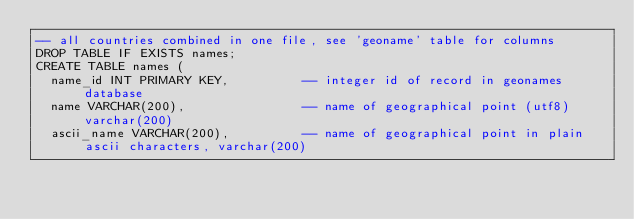Convert code to text. <code><loc_0><loc_0><loc_500><loc_500><_SQL_>-- all countries combined in one file, see 'geoname' table for columns
DROP TABLE IF EXISTS names;
CREATE TABLE names (
  name_id INT PRIMARY KEY,          -- integer id of record in geonames database
  name VARCHAR(200),                -- name of geographical point (utf8) varchar(200)
  ascii_name VARCHAR(200),          -- name of geographical point in plain ascii characters, varchar(200)</code> 